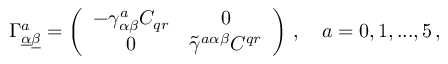<formula> <loc_0><loc_0><loc_500><loc_500>\Gamma _ { \underline { \alpha } \underline { \beta } } ^ { a } = \left ( \begin{array} { c c } { { - \gamma _ { \alpha \beta } ^ { a } C _ { q r } } } & { 0 } \\ { 0 } & { { \tilde { \gamma } ^ { a \alpha \beta } C ^ { q r } } } \end{array} \right ) \, , \quad a = 0 , 1 , \dots , 5 \, ,</formula> 